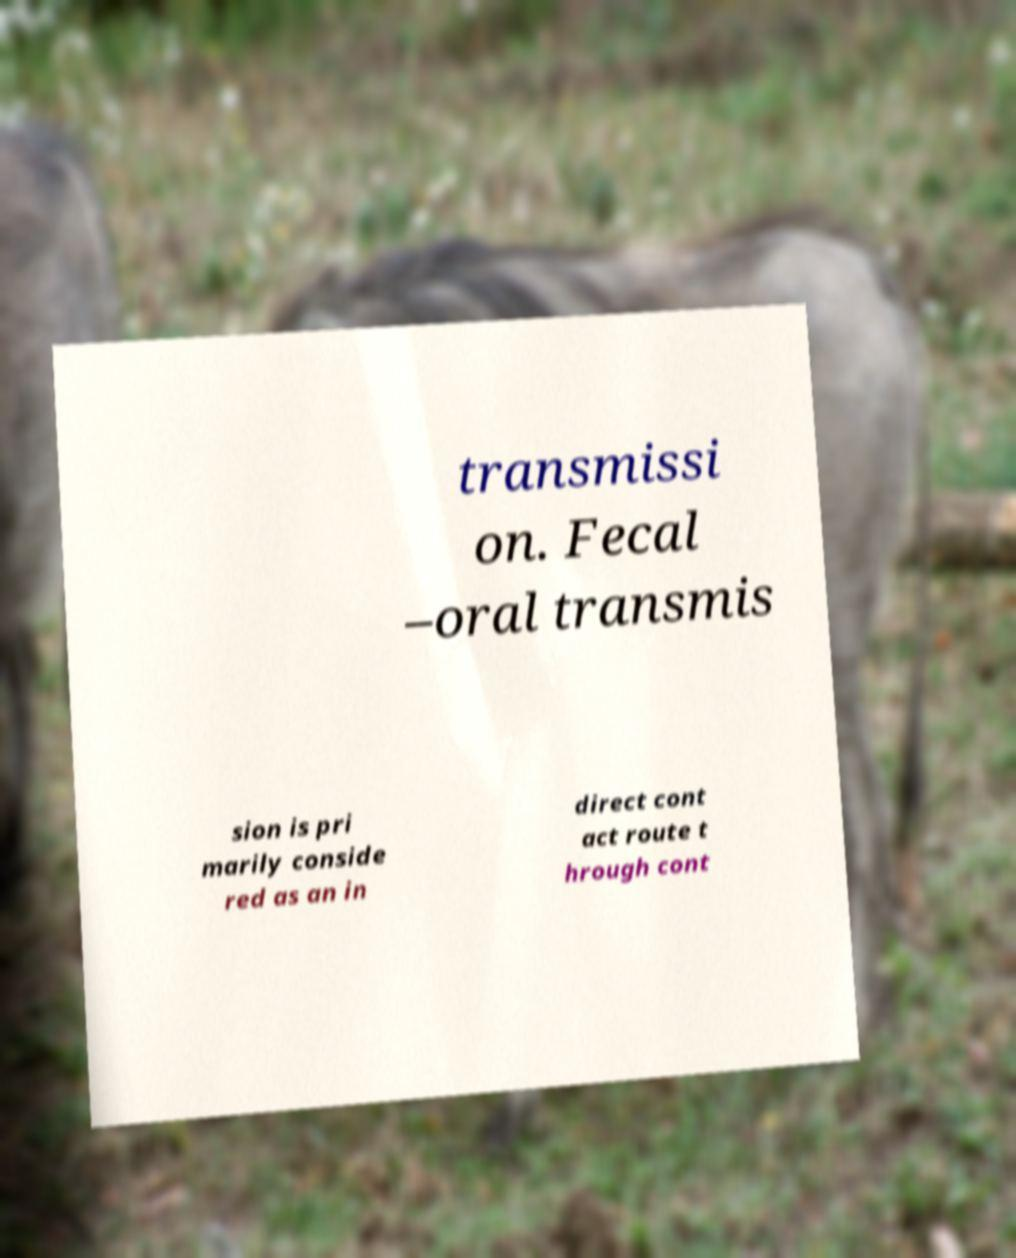There's text embedded in this image that I need extracted. Can you transcribe it verbatim? transmissi on. Fecal –oral transmis sion is pri marily conside red as an in direct cont act route t hrough cont 